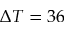Convert formula to latex. <formula><loc_0><loc_0><loc_500><loc_500>\Delta T = 3 6</formula> 